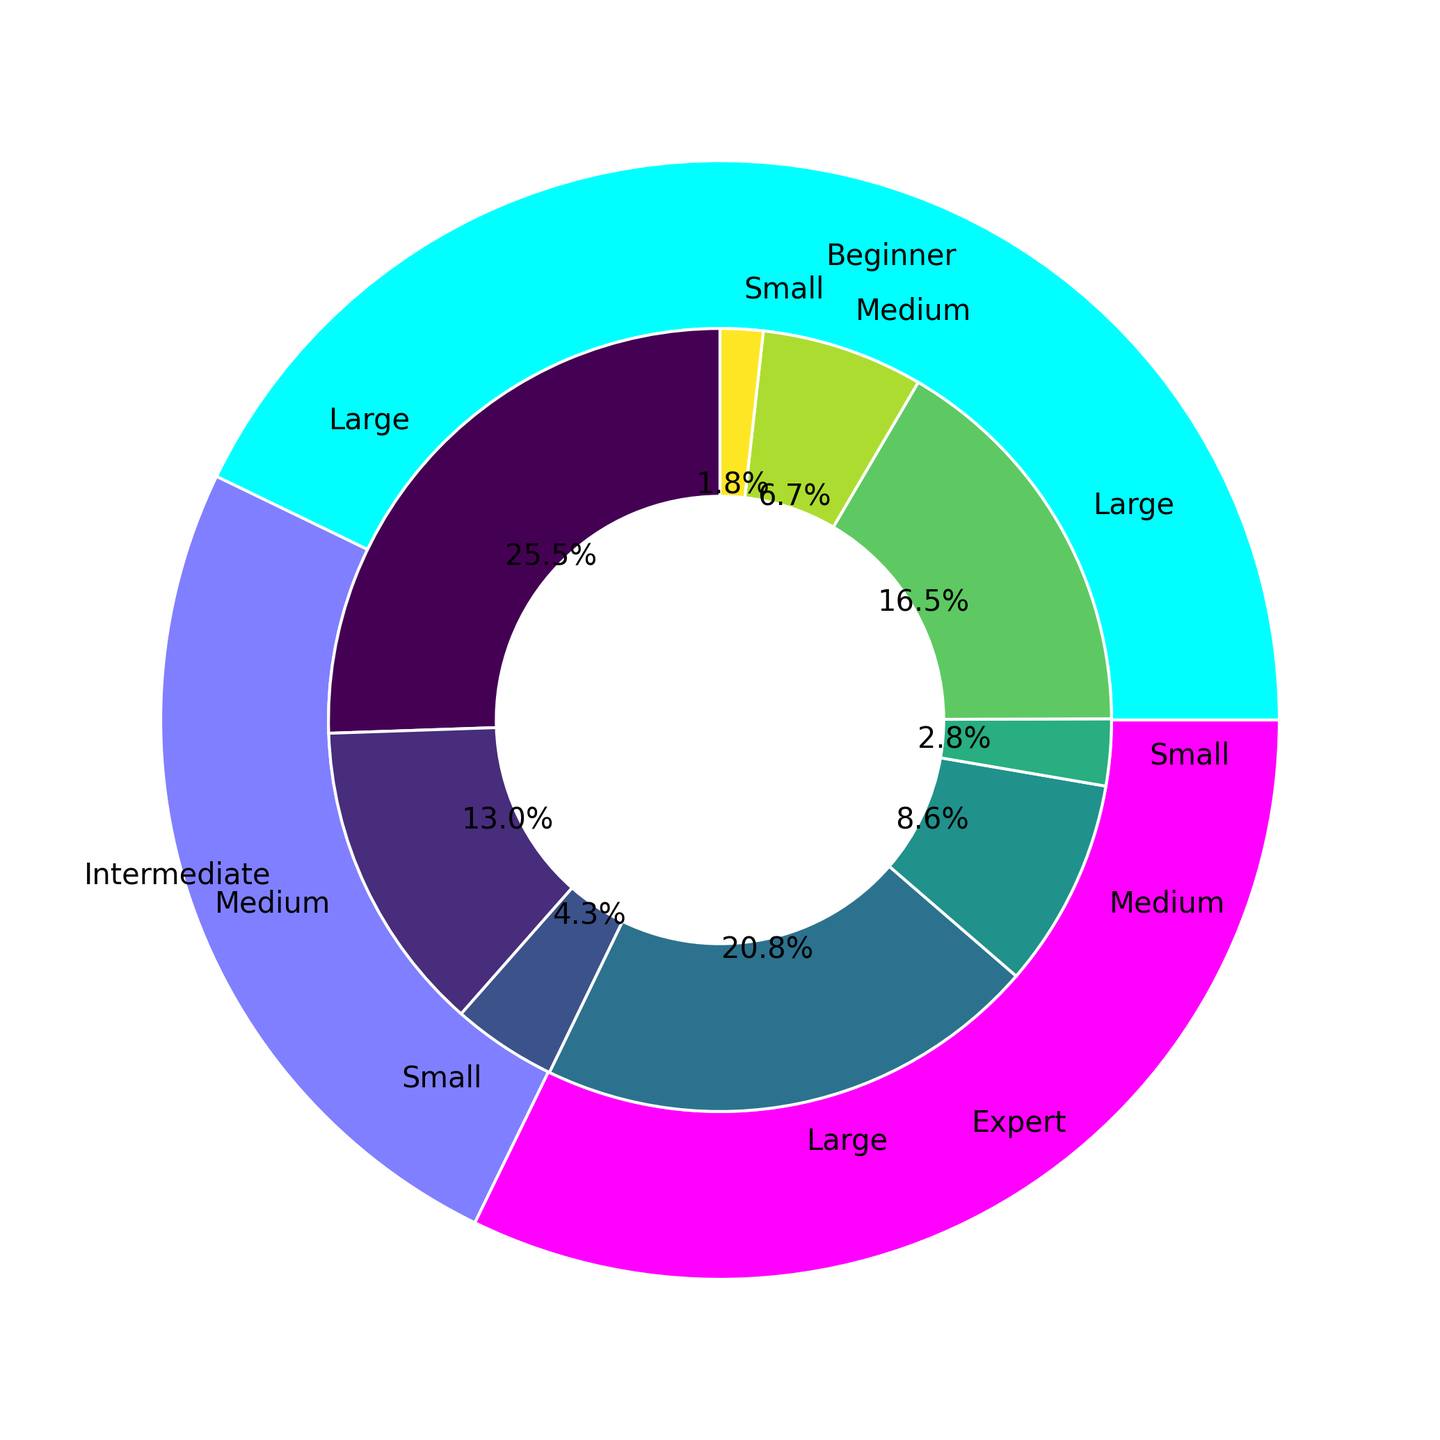What's the total time investment for Beginner skill level? Sum up all the time investment values for Beginner from the inner pie sections: 5+6+15+18+30+35 = 109 hours
Answer: 109 hours What's the fraction of time investment on Large projects by Experts? Sum the time investment for Large projects by Experts (20+22 = 42) and then divide by total Expert time investment (2+2.5+8+9+20+22). The fraction is 42 / 63.5 ≈ 0.661
Answer: Approx. 0.661 (66.1%) Which skill level has the smallest proportion of Small projects? Compare the relative sizes of the inner pie sections for Small projects among all skill levels: Beginner, Intermediate, Expert. The smallest proportion visually appears in the Expert category.
Answer: Expert How does the total time investment for Medium projects compare between Intermediate and Beginner skill levels? Sum up the time investment for Medium projects for each skill level: Beginner: 15+18 = 33 hours, Intermediate: 10+12 = 22 hours. Comparison is 33 > 22.
Answer: Beginner > Intermediate What color represents the Intermediate time investment? The outer pie chart's colors representing each skill level show Intermediate in the middle color band, which appears in the blue spectrum. Note: The exact shade should align with the viridis colormap used.
Answer: Blue (shaded) Which project size has the largest time investment in the Intermediate skill level? Compare the inner pie sections' sizes within Intermediate: Small (3+4 = 7), Medium (10+12 = 22), Large (25+28 = 53). The largest is Large projects.
Answer: Large What is the average time investment for Large projects by Intermediates? Sum the time investments for Large projects for Intermediates (25+28 = 53), then divide by the number of data points (2). The average is 53 / 2 = 26.5
Answer: 26.5 hours Calculate the difference between the total time investment in Small projects for Beginners and Experts. Sum the time investment for Small projects by Beginners (5+6 = 11) and Experts (2+2.5 = 4.5). Difference is 11 - 4.5 = 6.5
Answer: 6.5 hours Which skill level invests the most total hours in Medium-sized projects? Sum the time investments across Beginners, Intermediates, and Experts for Medium projects: Beginner (15+18 = 33), Intermediate (10+12 = 22), Expert (8+9 = 17). The highest is Beginners.
Answer: Beginner What is the proportional breakdown of time investment between Small, Medium, and Large projects within the Beginner skill level? Calculate the totals: Small (5+6 = 11), Medium (15+18 = 33), Large (30+35 = 65). The proportions are Small: 11/109 ≈ 0.101, Medium: 33/109 ≈ 0.303, Large: 65/109 ≈ 0.596
Answer: Small: 10.1%, Medium: 30.3%, Large: 59.6% 